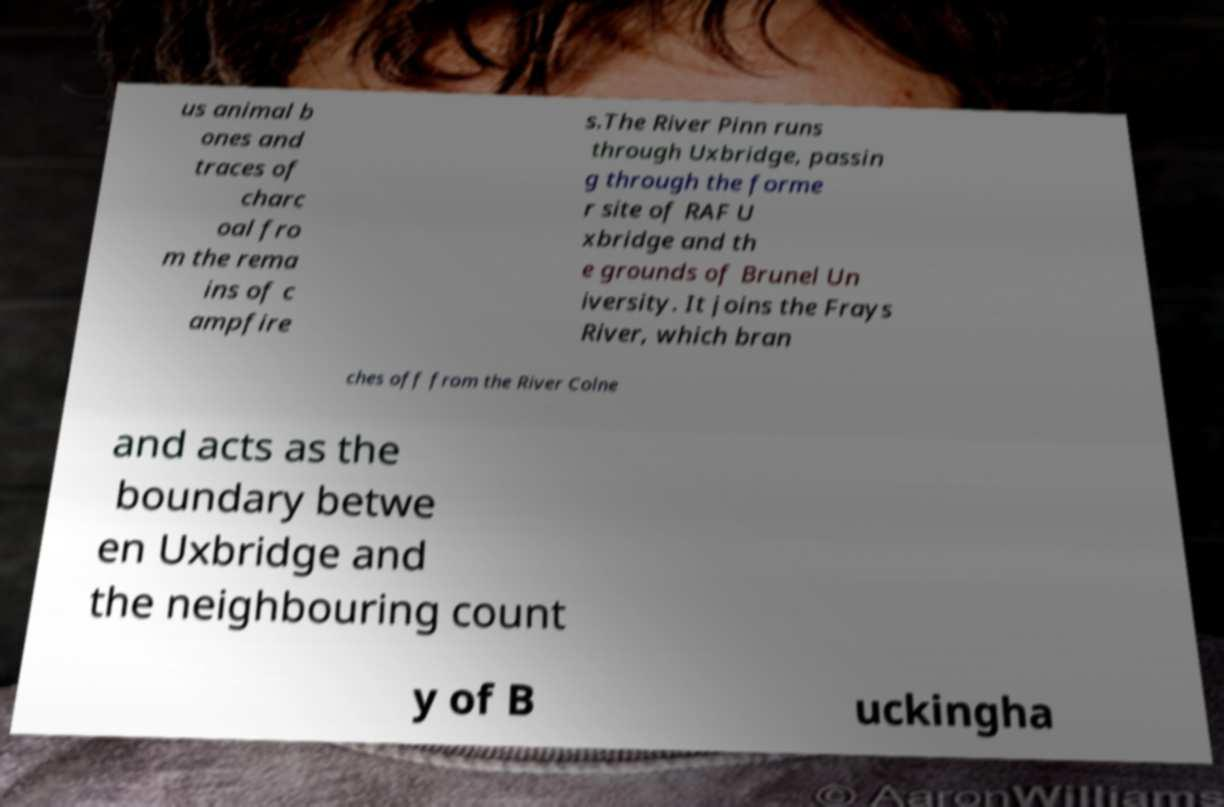Could you assist in decoding the text presented in this image and type it out clearly? us animal b ones and traces of charc oal fro m the rema ins of c ampfire s.The River Pinn runs through Uxbridge, passin g through the forme r site of RAF U xbridge and th e grounds of Brunel Un iversity. It joins the Frays River, which bran ches off from the River Colne and acts as the boundary betwe en Uxbridge and the neighbouring count y of B uckingha 